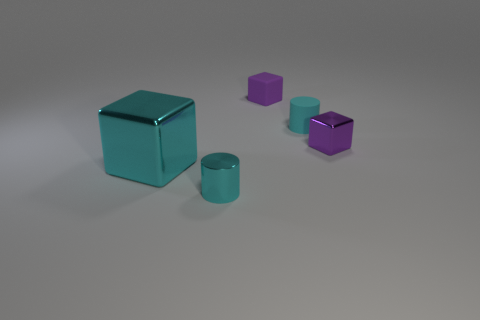Is there anything else of the same color as the large object?
Offer a terse response. Yes. What is the color of the small metallic thing that is to the right of the small cylinder that is in front of the big cyan block?
Ensure brevity in your answer.  Purple. What is the cyan object behind the cyan thing on the left side of the small cylinder in front of the purple metal block made of?
Keep it short and to the point. Rubber. How many yellow matte balls have the same size as the purple shiny block?
Provide a short and direct response. 0. The object that is both to the left of the small matte cylinder and behind the purple metal block is made of what material?
Offer a terse response. Rubber. How many small purple objects are to the right of the rubber cylinder?
Your answer should be very brief. 1. Does the tiny cyan matte thing have the same shape as the metallic object to the right of the cyan matte cylinder?
Keep it short and to the point. No. Are there any tiny cyan matte things of the same shape as the small purple metal thing?
Offer a very short reply. No. The small metal object in front of the purple object that is to the right of the small purple rubber object is what shape?
Give a very brief answer. Cylinder. What shape is the small thing that is in front of the cyan cube?
Offer a very short reply. Cylinder. 